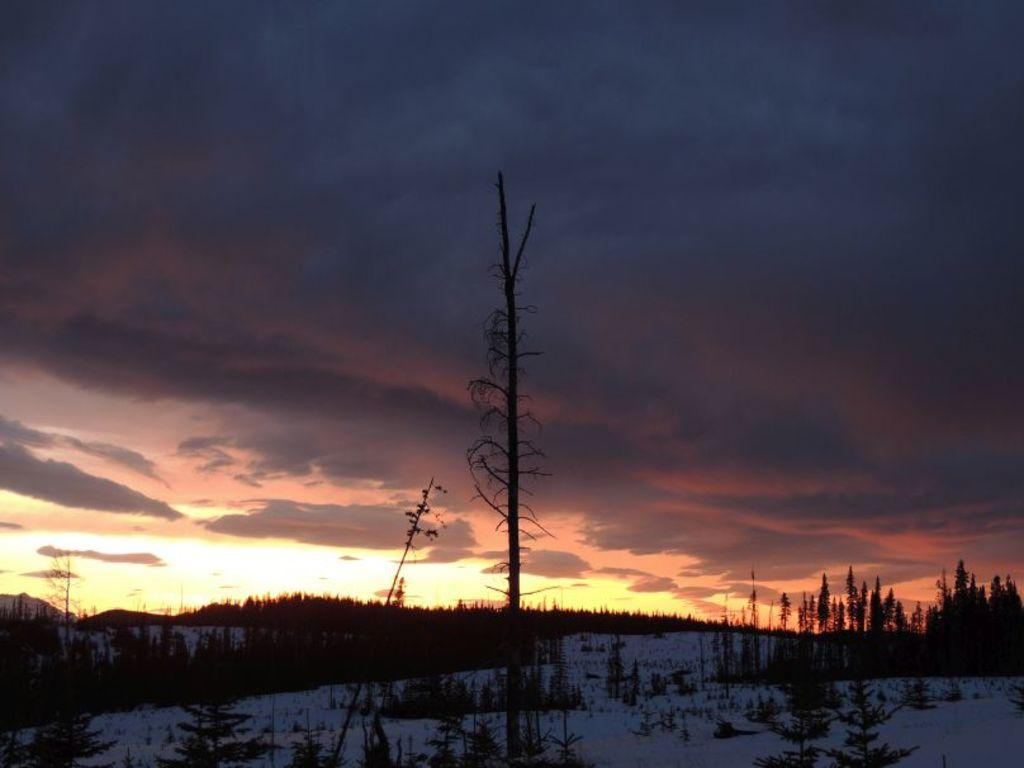What is the condition of the ground in the image? The ground is covered in snow. What type of vegetation can be seen in the image? There are trees visible in the image. What is visible in the sky in the image? Clouds are present in the sky, and the sky is visible in the image. How would you describe the lighting in the image? The image appears to be slightly dark. What grade did the tree receive in the competition in the image? There is no competition or grade mentioned in the image; it simply shows trees with snow on the ground. 